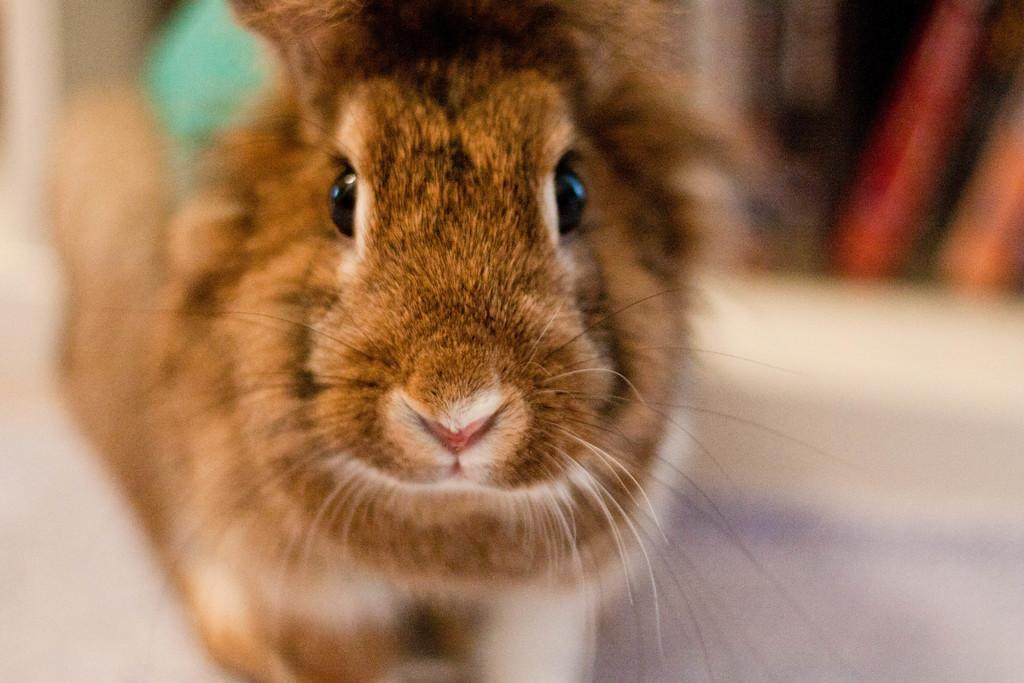What type of creature is in the picture? There is an animal in the picture, and it looks like a rat. Can you describe the background of the image? The background of the image is blurred. What type of basket is visible in the image? There is no basket present in the image. Can you describe the texture of the rat's fur in the image? The image quality is not sufficient to accurately describe the texture of the rat's fur. 